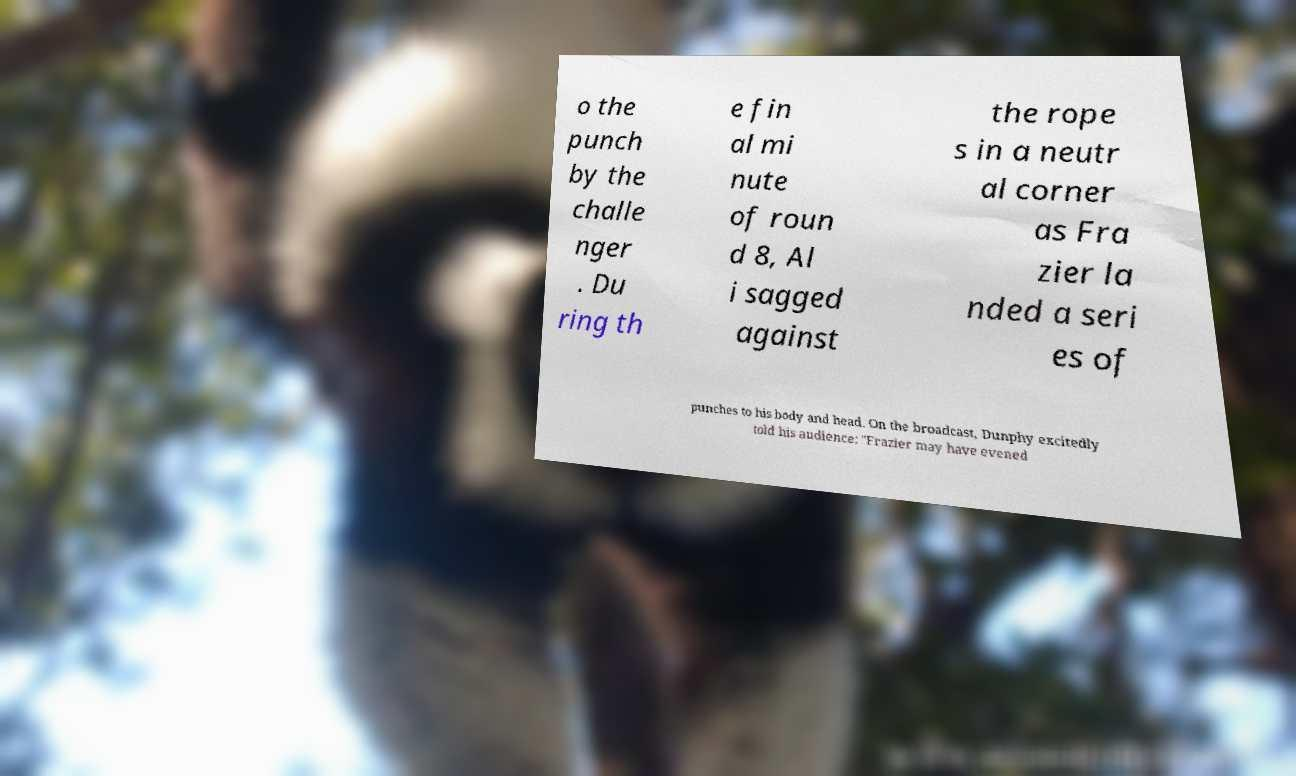Can you read and provide the text displayed in the image?This photo seems to have some interesting text. Can you extract and type it out for me? o the punch by the challe nger . Du ring th e fin al mi nute of roun d 8, Al i sagged against the rope s in a neutr al corner as Fra zier la nded a seri es of punches to his body and head. On the broadcast, Dunphy excitedly told his audience: "Frazier may have evened 